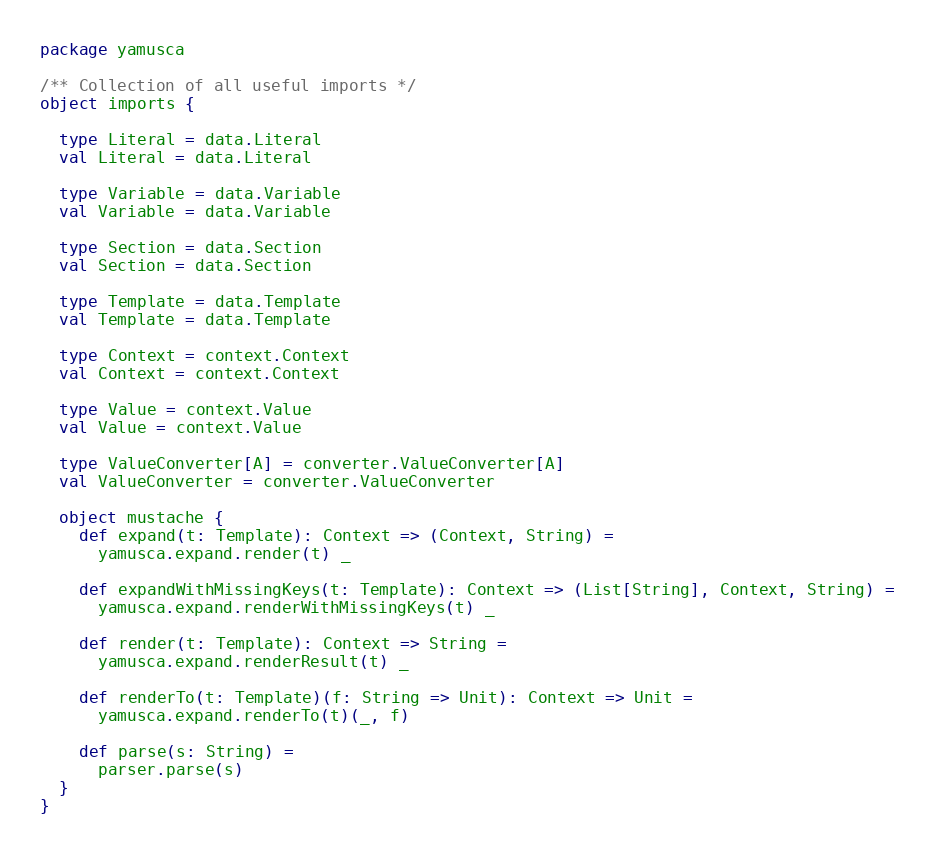<code> <loc_0><loc_0><loc_500><loc_500><_Scala_>package yamusca

/** Collection of all useful imports */
object imports {

  type Literal = data.Literal
  val Literal = data.Literal

  type Variable = data.Variable
  val Variable = data.Variable

  type Section = data.Section
  val Section = data.Section

  type Template = data.Template
  val Template = data.Template

  type Context = context.Context
  val Context = context.Context

  type Value = context.Value
  val Value = context.Value

  type ValueConverter[A] = converter.ValueConverter[A]
  val ValueConverter = converter.ValueConverter

  object mustache {
    def expand(t: Template): Context => (Context, String) =
      yamusca.expand.render(t) _

    def expandWithMissingKeys(t: Template): Context => (List[String], Context, String) =
      yamusca.expand.renderWithMissingKeys(t) _

    def render(t: Template): Context => String =
      yamusca.expand.renderResult(t) _

    def renderTo(t: Template)(f: String => Unit): Context => Unit =
      yamusca.expand.renderTo(t)(_, f)

    def parse(s: String) =
      parser.parse(s)
  }
}
</code> 